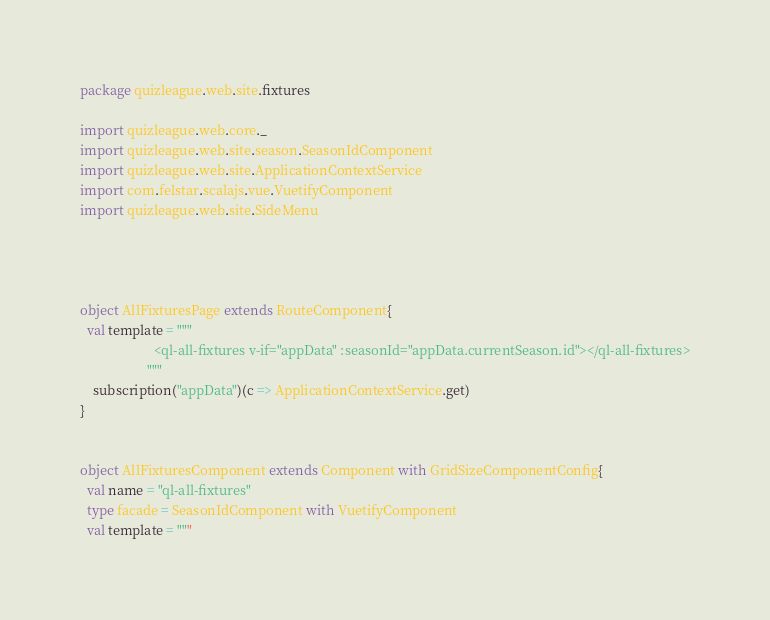Convert code to text. <code><loc_0><loc_0><loc_500><loc_500><_Scala_>package quizleague.web.site.fixtures

import quizleague.web.core._
import quizleague.web.site.season.SeasonIdComponent
import quizleague.web.site.ApplicationContextService
import com.felstar.scalajs.vue.VuetifyComponent
import quizleague.web.site.SideMenu




object AllFixturesPage extends RouteComponent{
  val template = """
                      <ql-all-fixtures v-if="appData" :seasonId="appData.currentSeason.id"></ql-all-fixtures>
                    """
    subscription("appData")(c => ApplicationContextService.get)
}


object AllFixturesComponent extends Component with GridSizeComponentConfig{
  val name = "ql-all-fixtures"
  type facade = SeasonIdComponent with VuetifyComponent
  val template = """</code> 